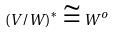<formula> <loc_0><loc_0><loc_500><loc_500>( V / W ) ^ { * } \cong W ^ { o }</formula> 